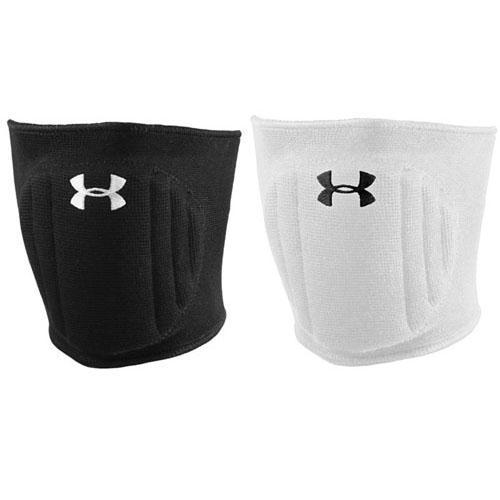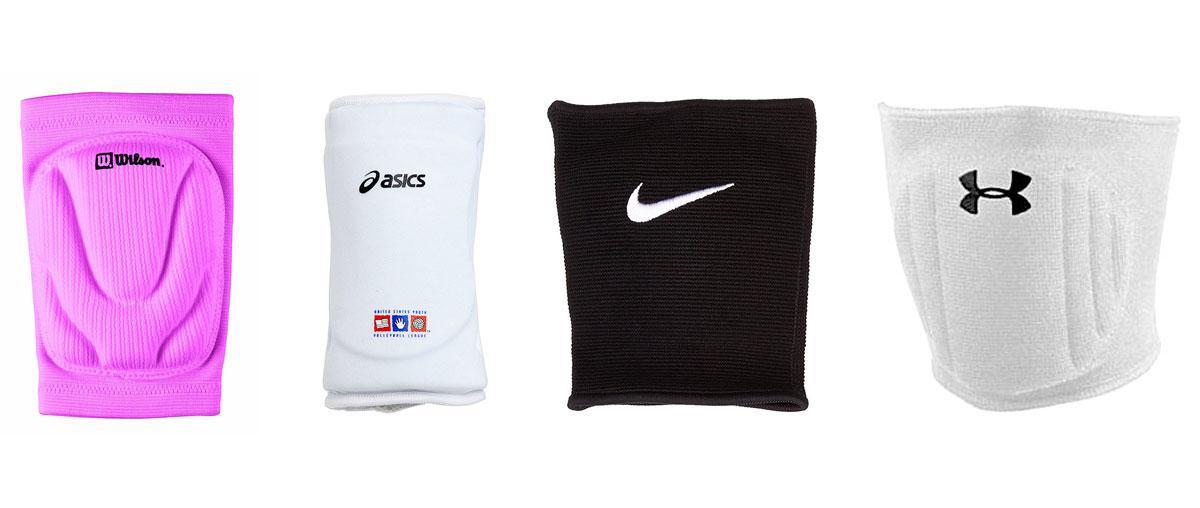The first image is the image on the left, the second image is the image on the right. Analyze the images presented: Is the assertion "There is one white and one black knee brace in the left image." valid? Answer yes or no. Yes. The first image is the image on the left, the second image is the image on the right. For the images shown, is this caption "Each image includes a black knee pad and a white knee pad." true? Answer yes or no. Yes. 